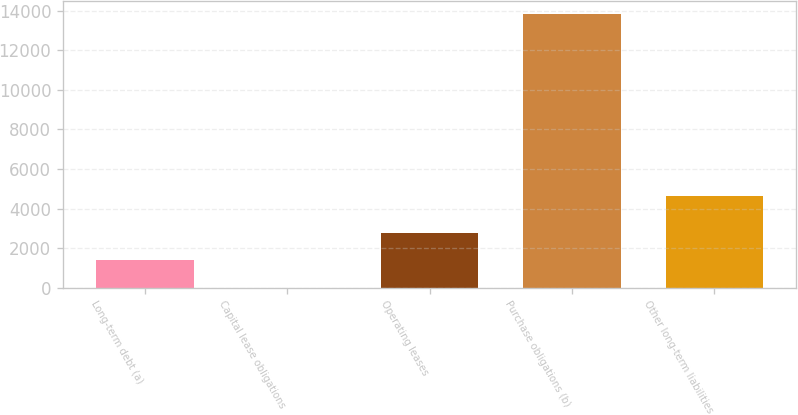Convert chart. <chart><loc_0><loc_0><loc_500><loc_500><bar_chart><fcel>Long-term debt (a)<fcel>Capital lease obligations<fcel>Operating leases<fcel>Purchase obligations (b)<fcel>Other long-term liabilities<nl><fcel>1382.4<fcel>2<fcel>2762.8<fcel>13806<fcel>4632<nl></chart> 